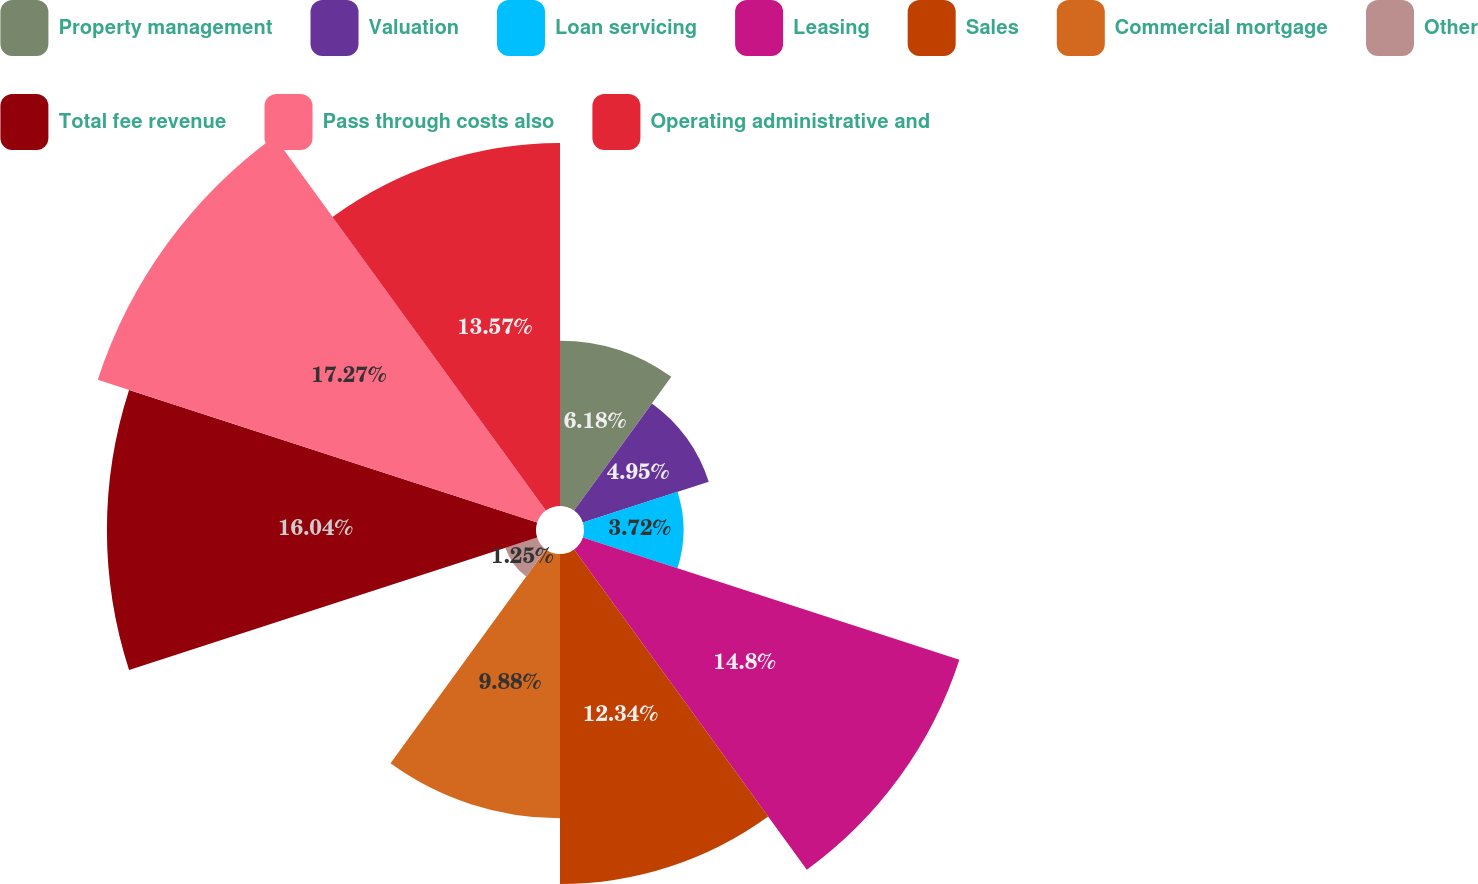Convert chart. <chart><loc_0><loc_0><loc_500><loc_500><pie_chart><fcel>Property management<fcel>Valuation<fcel>Loan servicing<fcel>Leasing<fcel>Sales<fcel>Commercial mortgage<fcel>Other<fcel>Total fee revenue<fcel>Pass through costs also<fcel>Operating administrative and<nl><fcel>6.18%<fcel>4.95%<fcel>3.72%<fcel>14.8%<fcel>12.34%<fcel>9.88%<fcel>1.25%<fcel>16.04%<fcel>17.27%<fcel>13.57%<nl></chart> 